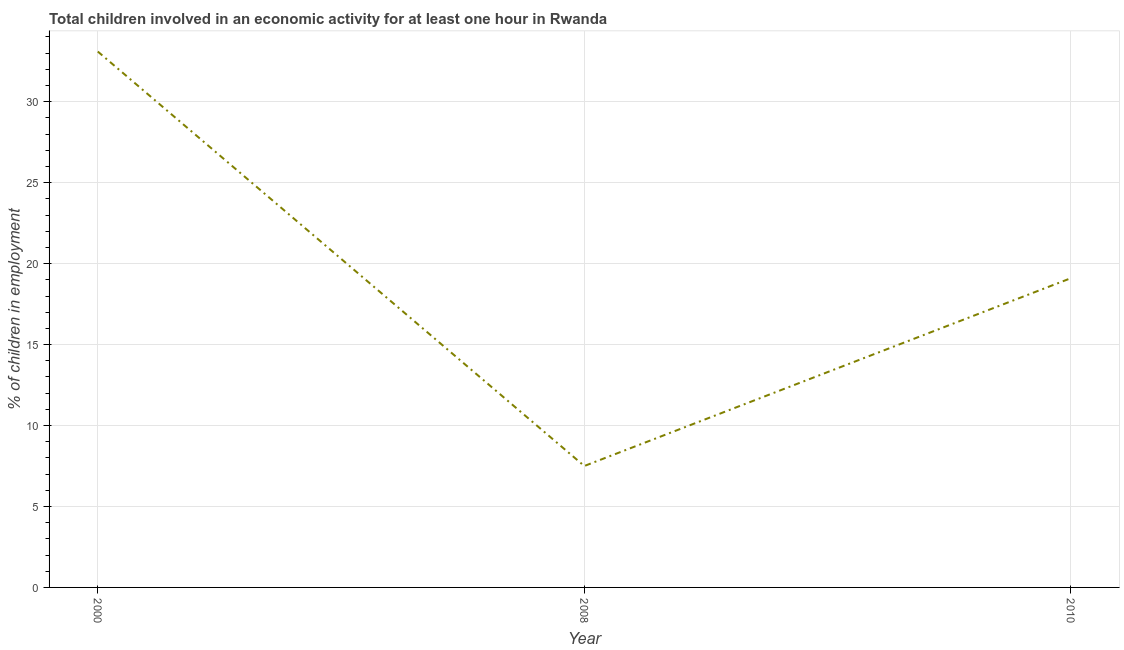What is the percentage of children in employment in 2010?
Make the answer very short. 19.1. Across all years, what is the maximum percentage of children in employment?
Give a very brief answer. 33.1. Across all years, what is the minimum percentage of children in employment?
Your response must be concise. 7.5. In which year was the percentage of children in employment minimum?
Make the answer very short. 2008. What is the sum of the percentage of children in employment?
Make the answer very short. 59.7. What is the difference between the percentage of children in employment in 2000 and 2008?
Make the answer very short. 25.6. What is the average percentage of children in employment per year?
Keep it short and to the point. 19.9. In how many years, is the percentage of children in employment greater than 17 %?
Ensure brevity in your answer.  2. What is the ratio of the percentage of children in employment in 2000 to that in 2010?
Provide a succinct answer. 1.73. Is the percentage of children in employment in 2000 less than that in 2010?
Your answer should be very brief. No. Is the sum of the percentage of children in employment in 2000 and 2010 greater than the maximum percentage of children in employment across all years?
Provide a short and direct response. Yes. What is the difference between the highest and the lowest percentage of children in employment?
Provide a succinct answer. 25.6. In how many years, is the percentage of children in employment greater than the average percentage of children in employment taken over all years?
Your answer should be compact. 1. What is the difference between two consecutive major ticks on the Y-axis?
Provide a succinct answer. 5. Are the values on the major ticks of Y-axis written in scientific E-notation?
Keep it short and to the point. No. What is the title of the graph?
Offer a very short reply. Total children involved in an economic activity for at least one hour in Rwanda. What is the label or title of the X-axis?
Make the answer very short. Year. What is the label or title of the Y-axis?
Provide a short and direct response. % of children in employment. What is the % of children in employment of 2000?
Your answer should be very brief. 33.1. What is the % of children in employment in 2008?
Provide a short and direct response. 7.5. What is the % of children in employment in 2010?
Make the answer very short. 19.1. What is the difference between the % of children in employment in 2000 and 2008?
Your answer should be compact. 25.6. What is the ratio of the % of children in employment in 2000 to that in 2008?
Provide a succinct answer. 4.41. What is the ratio of the % of children in employment in 2000 to that in 2010?
Keep it short and to the point. 1.73. What is the ratio of the % of children in employment in 2008 to that in 2010?
Provide a short and direct response. 0.39. 